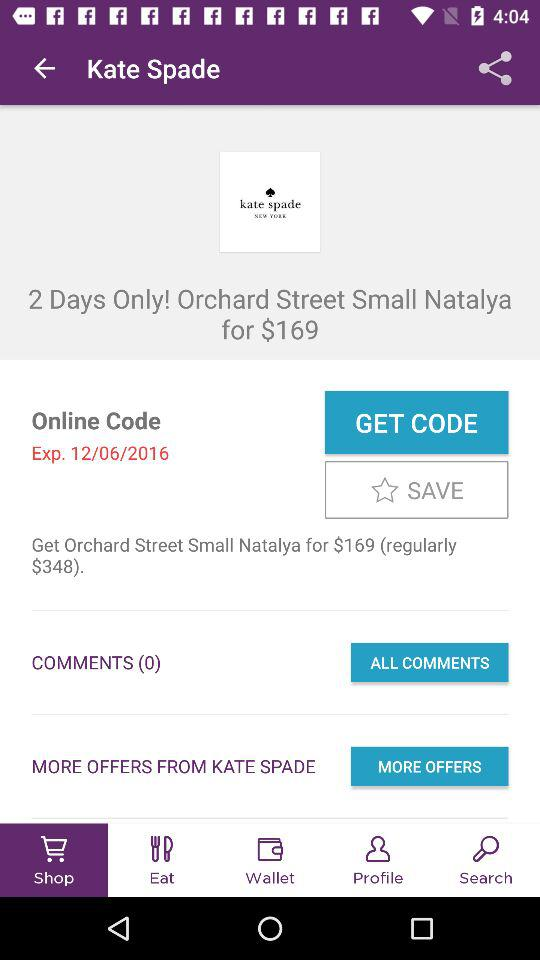How much is the original price of the product?
Answer the question using a single word or phrase. $348 